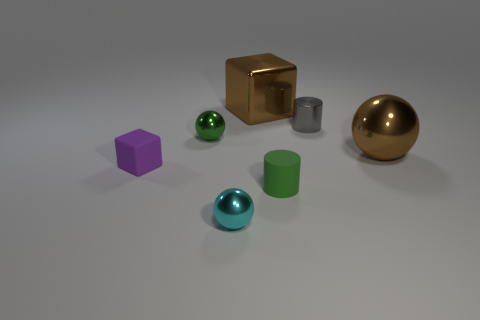Add 1 large metallic blocks. How many objects exist? 8 Subtract all cylinders. How many objects are left? 5 Subtract 0 blue cubes. How many objects are left? 7 Subtract all large cyan matte things. Subtract all tiny green shiny balls. How many objects are left? 6 Add 5 cyan things. How many cyan things are left? 6 Add 3 cyan metallic balls. How many cyan metallic balls exist? 4 